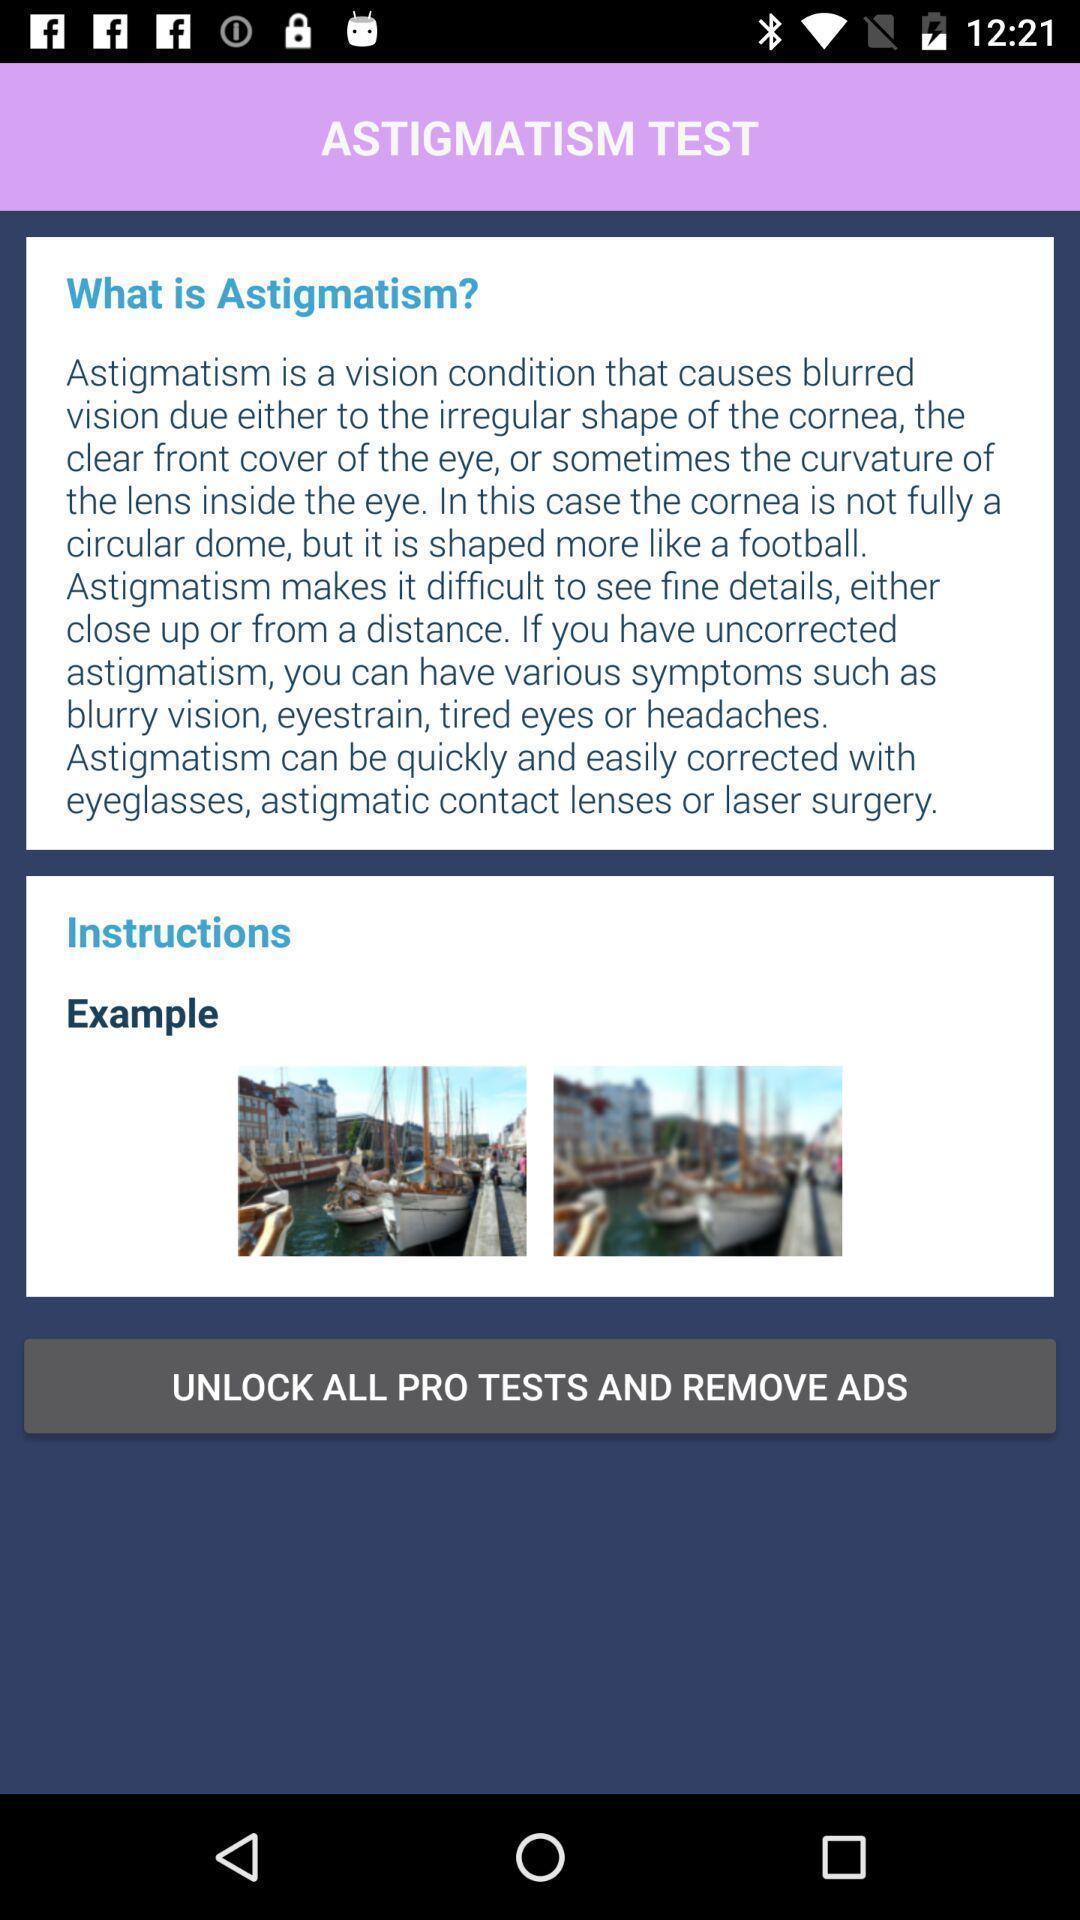Provide a description of this screenshot. Screen page of a eye testing app. 